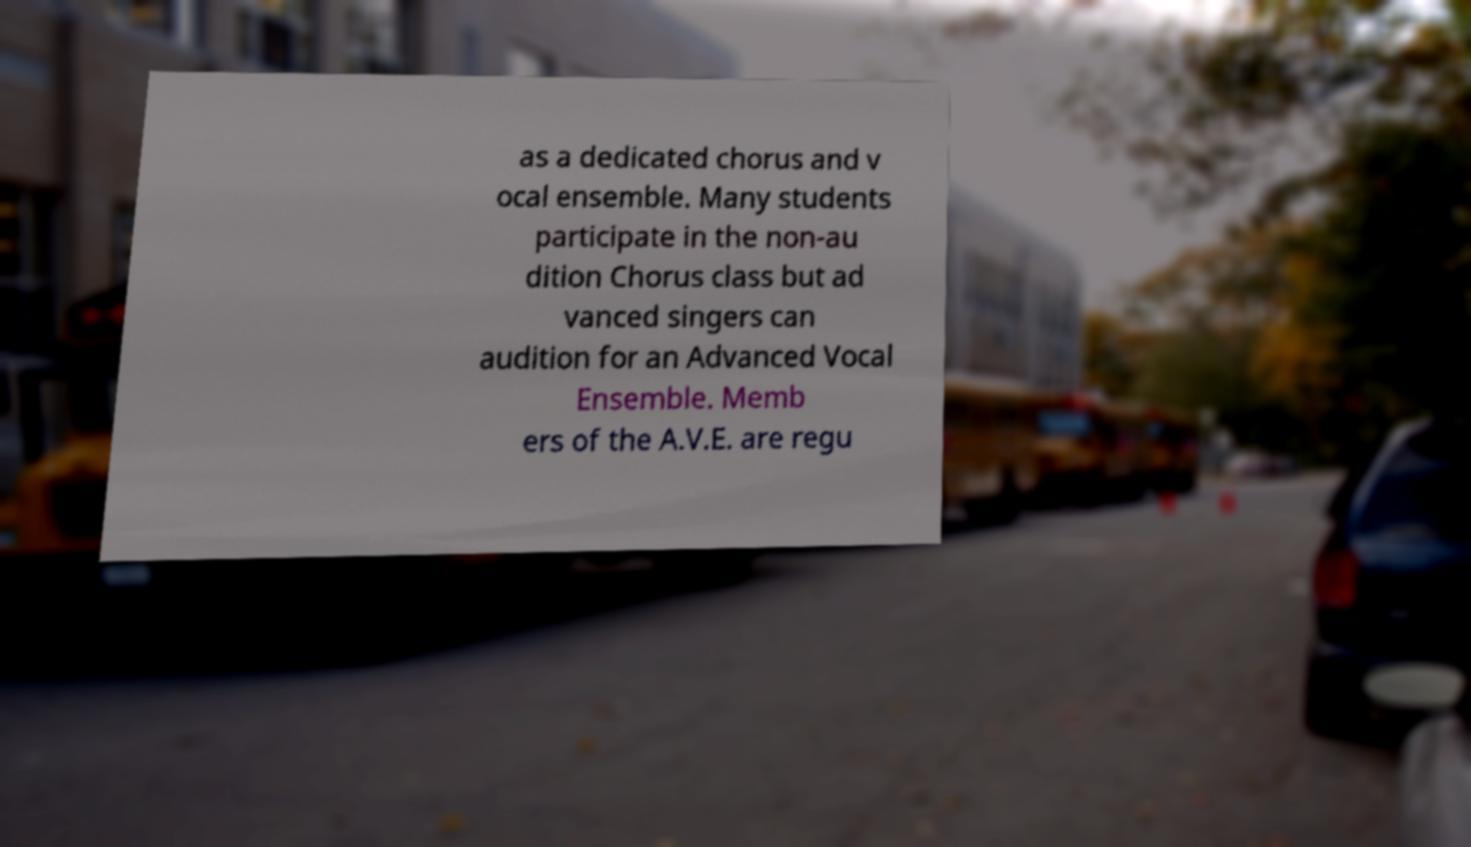I need the written content from this picture converted into text. Can you do that? as a dedicated chorus and v ocal ensemble. Many students participate in the non-au dition Chorus class but ad vanced singers can audition for an Advanced Vocal Ensemble. Memb ers of the A.V.E. are regu 